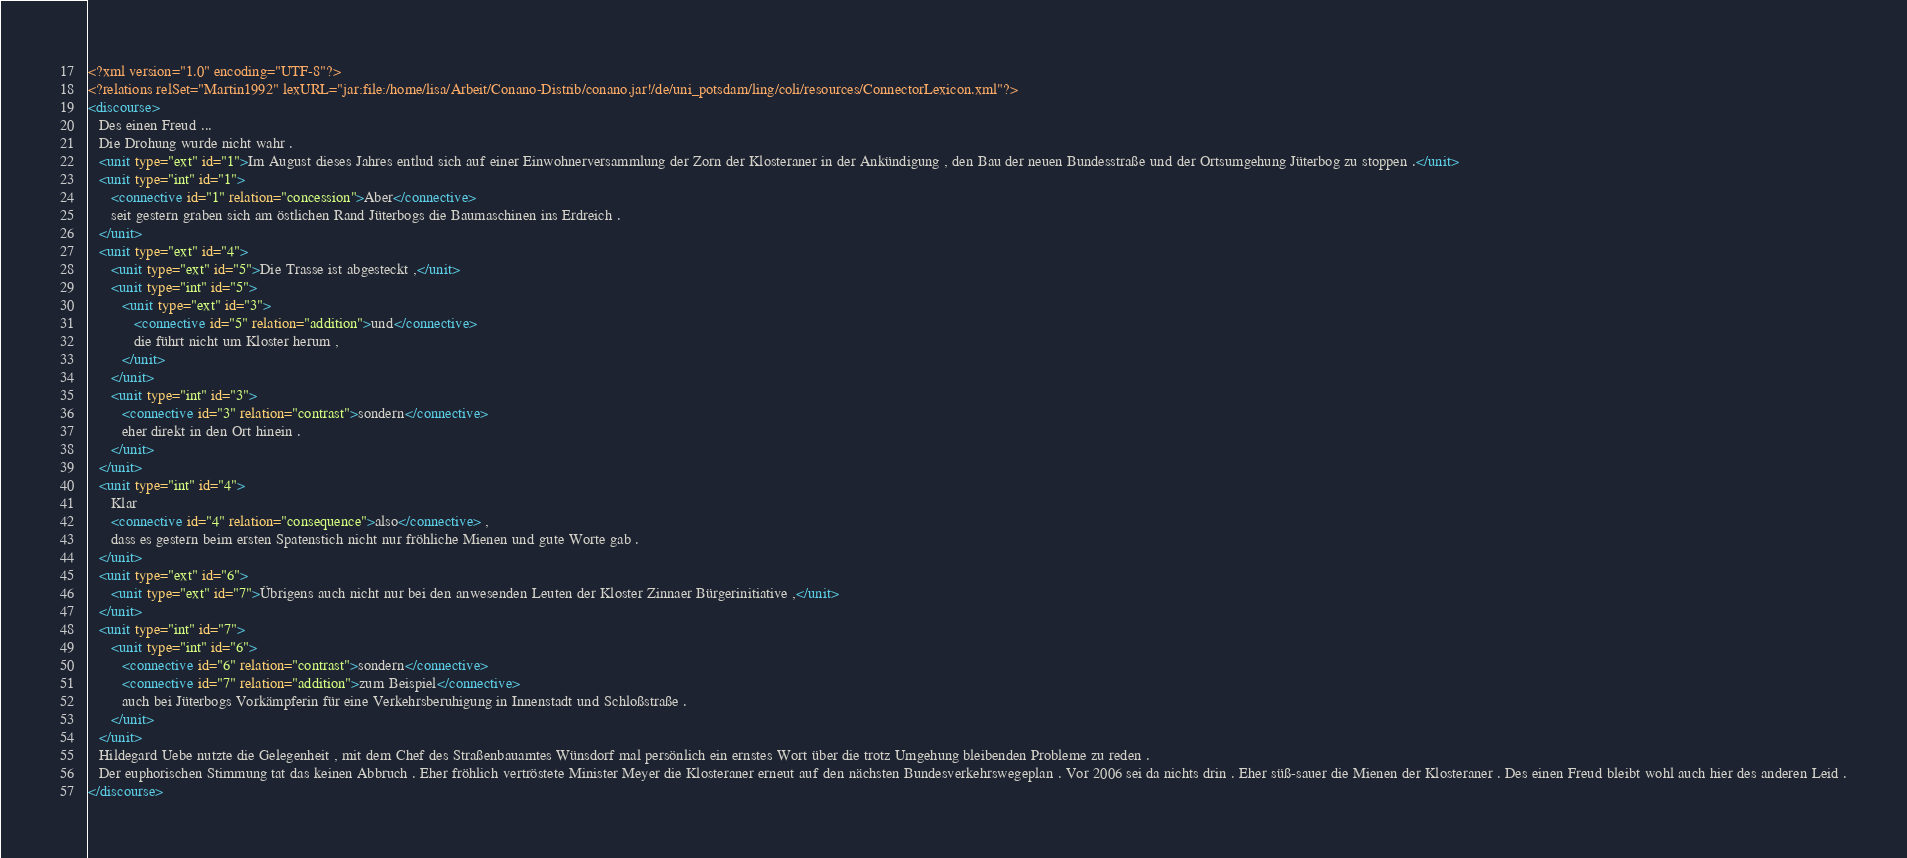<code> <loc_0><loc_0><loc_500><loc_500><_XML_><?xml version="1.0" encoding="UTF-8"?>
<?relations relSet="Martin1992" lexURL="jar:file:/home/lisa/Arbeit/Conano-Distrib/conano.jar!/de/uni_potsdam/ling/coli/resources/ConnectorLexicon.xml"?>
<discourse>
   Des einen Freud ...
   Die Drohung wurde nicht wahr .
   <unit type="ext" id="1">Im August dieses Jahres entlud sich auf einer Einwohnerversammlung der Zorn der Klosteraner in der Ankündigung , den Bau der neuen Bundesstraße und der Ortsumgehung Jüterbog zu stoppen .</unit>
   <unit type="int" id="1">
      <connective id="1" relation="concession">Aber</connective>
      seit gestern graben sich am östlichen Rand Jüterbogs die Baumaschinen ins Erdreich .
   </unit>
   <unit type="ext" id="4">
      <unit type="ext" id="5">Die Trasse ist abgesteckt ,</unit>
      <unit type="int" id="5">
         <unit type="ext" id="3">
            <connective id="5" relation="addition">und</connective>
            die führt nicht um Kloster herum ,
         </unit>
      </unit>
      <unit type="int" id="3">
         <connective id="3" relation="contrast">sondern</connective>
         eher direkt in den Ort hinein .
      </unit>
   </unit>
   <unit type="int" id="4">
      Klar
      <connective id="4" relation="consequence">also</connective> ,
      dass es gestern beim ersten Spatenstich nicht nur fröhliche Mienen und gute Worte gab .
   </unit>
   <unit type="ext" id="6">
      <unit type="ext" id="7">Übrigens auch nicht nur bei den anwesenden Leuten der Kloster Zinnaer Bürgerinitiative ,</unit>
   </unit>
   <unit type="int" id="7">
      <unit type="int" id="6">
         <connective id="6" relation="contrast">sondern</connective>
         <connective id="7" relation="addition">zum Beispiel</connective>
         auch bei Jüterbogs Vorkämpferin für eine Verkehrsberuhigung in Innenstadt und Schloßstraße .
      </unit>
   </unit>
   Hildegard Uebe nutzte die Gelegenheit , mit dem Chef des Straßenbauamtes Wünsdorf mal persönlich ein ernstes Wort über die trotz Umgehung bleibenden Probleme zu reden .
   Der euphorischen Stimmung tat das keinen Abbruch . Eher fröhlich vertröstete Minister Meyer die Klosteraner erneut auf den nächsten Bundesverkehrswegeplan . Vor 2006 sei da nichts drin . Eher süß-sauer die Mienen der Klosteraner . Des einen Freud bleibt wohl auch hier des anderen Leid .
</discourse>

</code> 